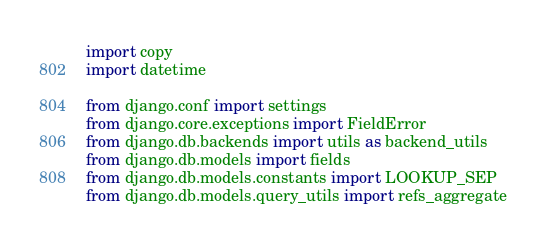<code> <loc_0><loc_0><loc_500><loc_500><_Python_>import copy
import datetime

from django.conf import settings
from django.core.exceptions import FieldError
from django.db.backends import utils as backend_utils
from django.db.models import fields
from django.db.models.constants import LOOKUP_SEP
from django.db.models.query_utils import refs_aggregate</code> 